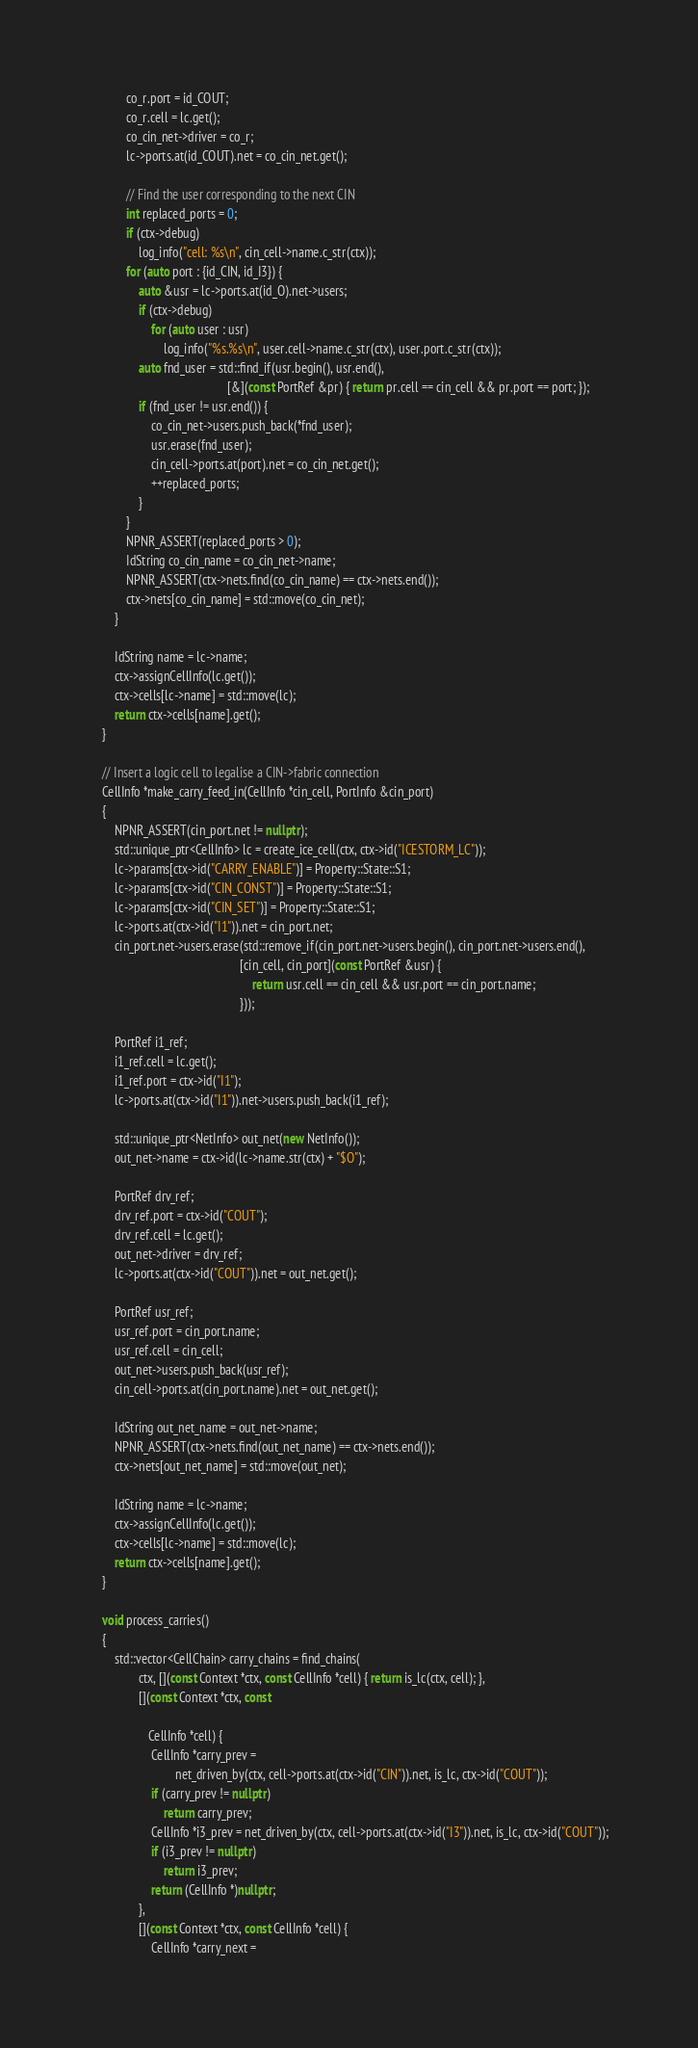<code> <loc_0><loc_0><loc_500><loc_500><_C++_>            co_r.port = id_COUT;
            co_r.cell = lc.get();
            co_cin_net->driver = co_r;
            lc->ports.at(id_COUT).net = co_cin_net.get();

            // Find the user corresponding to the next CIN
            int replaced_ports = 0;
            if (ctx->debug)
                log_info("cell: %s\n", cin_cell->name.c_str(ctx));
            for (auto port : {id_CIN, id_I3}) {
                auto &usr = lc->ports.at(id_O).net->users;
                if (ctx->debug)
                    for (auto user : usr)
                        log_info("%s.%s\n", user.cell->name.c_str(ctx), user.port.c_str(ctx));
                auto fnd_user = std::find_if(usr.begin(), usr.end(),
                                             [&](const PortRef &pr) { return pr.cell == cin_cell && pr.port == port; });
                if (fnd_user != usr.end()) {
                    co_cin_net->users.push_back(*fnd_user);
                    usr.erase(fnd_user);
                    cin_cell->ports.at(port).net = co_cin_net.get();
                    ++replaced_ports;
                }
            }
            NPNR_ASSERT(replaced_ports > 0);
            IdString co_cin_name = co_cin_net->name;
            NPNR_ASSERT(ctx->nets.find(co_cin_name) == ctx->nets.end());
            ctx->nets[co_cin_name] = std::move(co_cin_net);
        }

        IdString name = lc->name;
        ctx->assignCellInfo(lc.get());
        ctx->cells[lc->name] = std::move(lc);
        return ctx->cells[name].get();
    }

    // Insert a logic cell to legalise a CIN->fabric connection
    CellInfo *make_carry_feed_in(CellInfo *cin_cell, PortInfo &cin_port)
    {
        NPNR_ASSERT(cin_port.net != nullptr);
        std::unique_ptr<CellInfo> lc = create_ice_cell(ctx, ctx->id("ICESTORM_LC"));
        lc->params[ctx->id("CARRY_ENABLE")] = Property::State::S1;
        lc->params[ctx->id("CIN_CONST")] = Property::State::S1;
        lc->params[ctx->id("CIN_SET")] = Property::State::S1;
        lc->ports.at(ctx->id("I1")).net = cin_port.net;
        cin_port.net->users.erase(std::remove_if(cin_port.net->users.begin(), cin_port.net->users.end(),
                                                 [cin_cell, cin_port](const PortRef &usr) {
                                                     return usr.cell == cin_cell && usr.port == cin_port.name;
                                                 }));

        PortRef i1_ref;
        i1_ref.cell = lc.get();
        i1_ref.port = ctx->id("I1");
        lc->ports.at(ctx->id("I1")).net->users.push_back(i1_ref);

        std::unique_ptr<NetInfo> out_net(new NetInfo());
        out_net->name = ctx->id(lc->name.str(ctx) + "$O");

        PortRef drv_ref;
        drv_ref.port = ctx->id("COUT");
        drv_ref.cell = lc.get();
        out_net->driver = drv_ref;
        lc->ports.at(ctx->id("COUT")).net = out_net.get();

        PortRef usr_ref;
        usr_ref.port = cin_port.name;
        usr_ref.cell = cin_cell;
        out_net->users.push_back(usr_ref);
        cin_cell->ports.at(cin_port.name).net = out_net.get();

        IdString out_net_name = out_net->name;
        NPNR_ASSERT(ctx->nets.find(out_net_name) == ctx->nets.end());
        ctx->nets[out_net_name] = std::move(out_net);

        IdString name = lc->name;
        ctx->assignCellInfo(lc.get());
        ctx->cells[lc->name] = std::move(lc);
        return ctx->cells[name].get();
    }

    void process_carries()
    {
        std::vector<CellChain> carry_chains = find_chains(
                ctx, [](const Context *ctx, const CellInfo *cell) { return is_lc(ctx, cell); },
                [](const Context *ctx, const

                   CellInfo *cell) {
                    CellInfo *carry_prev =
                            net_driven_by(ctx, cell->ports.at(ctx->id("CIN")).net, is_lc, ctx->id("COUT"));
                    if (carry_prev != nullptr)
                        return carry_prev;
                    CellInfo *i3_prev = net_driven_by(ctx, cell->ports.at(ctx->id("I3")).net, is_lc, ctx->id("COUT"));
                    if (i3_prev != nullptr)
                        return i3_prev;
                    return (CellInfo *)nullptr;
                },
                [](const Context *ctx, const CellInfo *cell) {
                    CellInfo *carry_next =</code> 